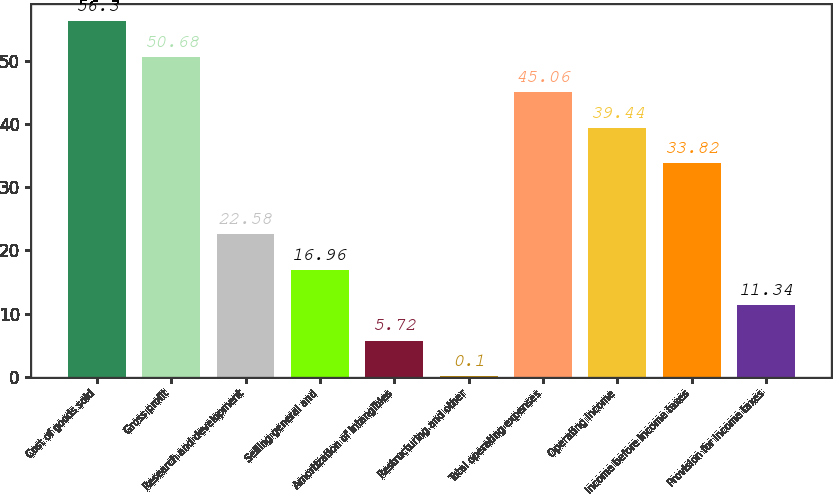Convert chart to OTSL. <chart><loc_0><loc_0><loc_500><loc_500><bar_chart><fcel>Cost of goods sold<fcel>Gross profit<fcel>Research and development<fcel>Selling general and<fcel>Amortization of intangibles<fcel>Restructuring and other<fcel>Total operating expenses<fcel>Operating income<fcel>Income before income taxes<fcel>Provision for income taxes<nl><fcel>56.3<fcel>50.68<fcel>22.58<fcel>16.96<fcel>5.72<fcel>0.1<fcel>45.06<fcel>39.44<fcel>33.82<fcel>11.34<nl></chart> 